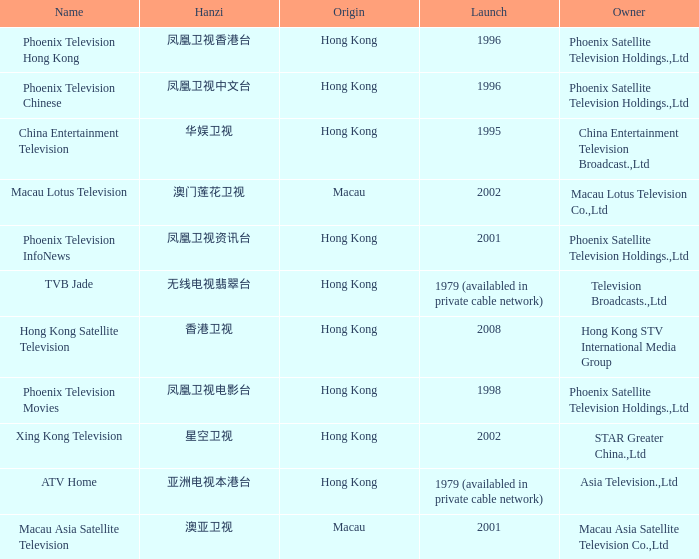What is the Hanzi of Phoenix Television Chinese that launched in 1996? 凤凰卫视中文台. 